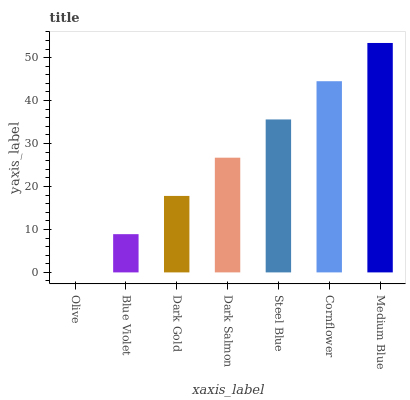Is Olive the minimum?
Answer yes or no. Yes. Is Medium Blue the maximum?
Answer yes or no. Yes. Is Blue Violet the minimum?
Answer yes or no. No. Is Blue Violet the maximum?
Answer yes or no. No. Is Blue Violet greater than Olive?
Answer yes or no. Yes. Is Olive less than Blue Violet?
Answer yes or no. Yes. Is Olive greater than Blue Violet?
Answer yes or no. No. Is Blue Violet less than Olive?
Answer yes or no. No. Is Dark Salmon the high median?
Answer yes or no. Yes. Is Dark Salmon the low median?
Answer yes or no. Yes. Is Olive the high median?
Answer yes or no. No. Is Cornflower the low median?
Answer yes or no. No. 